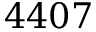Convert formula to latex. <formula><loc_0><loc_0><loc_500><loc_500>4 4 0 7</formula> 